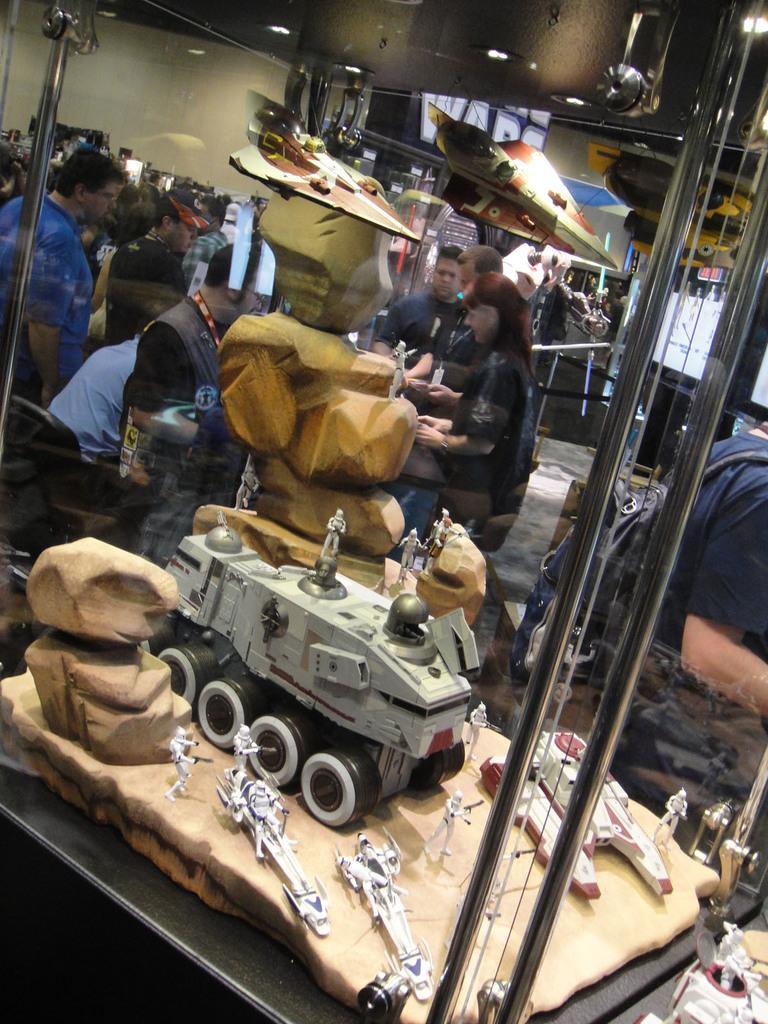Please provide a concise description of this image. In this image we can see group of people standing. In the foreground of the image we can see toys inside a glass door. In the background we can see a plane and some lights. 